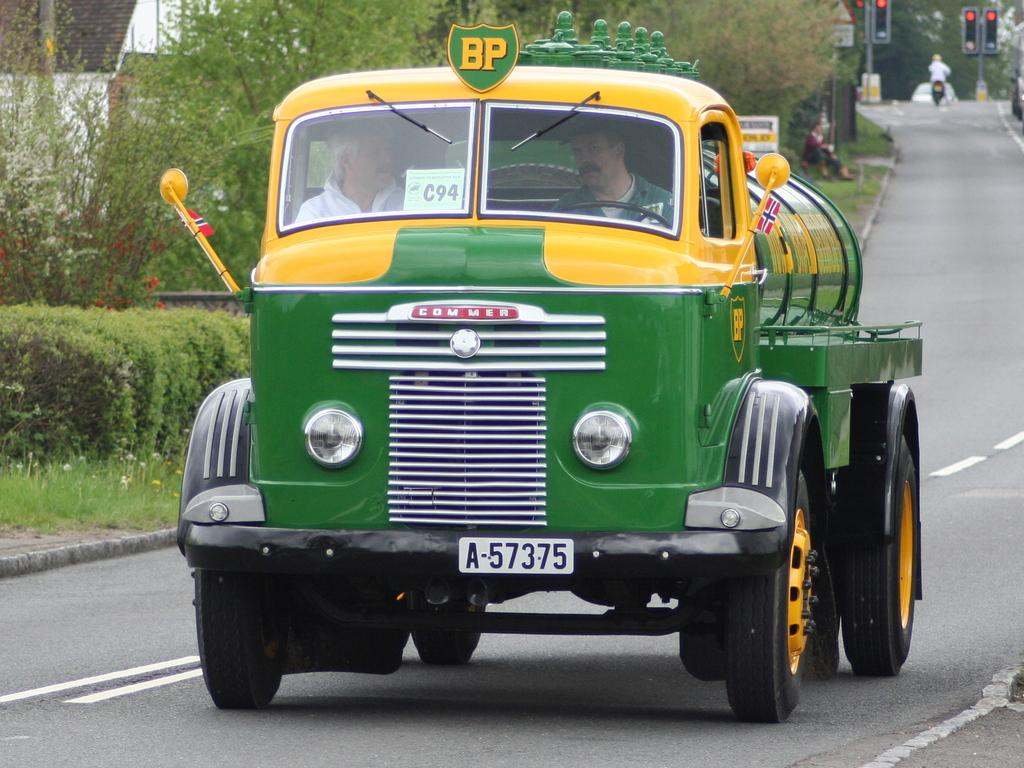<image>
Share a concise interpretation of the image provided. a green and yellow BP tanker with licence plate a-57375 